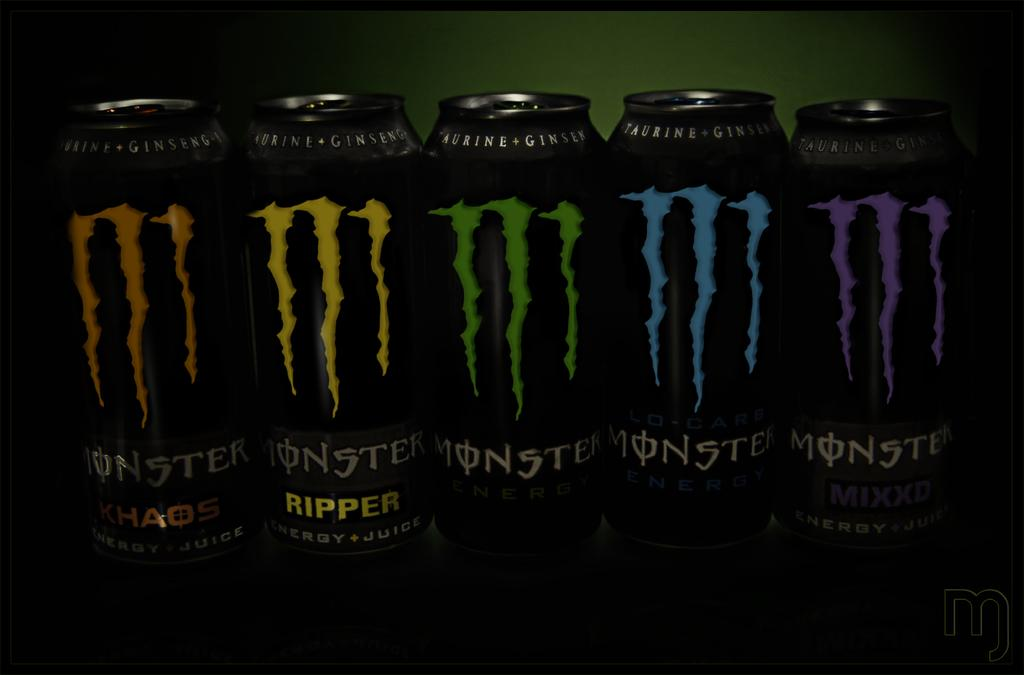<image>
Present a compact description of the photo's key features. In a row are five different cans of Monster Engergy, including Choas, Ripper, and Mixxd. 